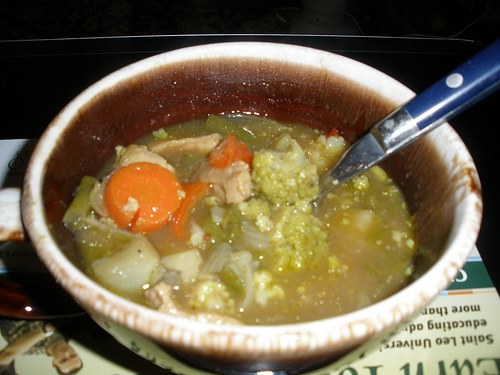Is the onion to the left of the food cooked and red? No, the onion to the left of the food is not red. It appears to be a standard white or yellow onion. 